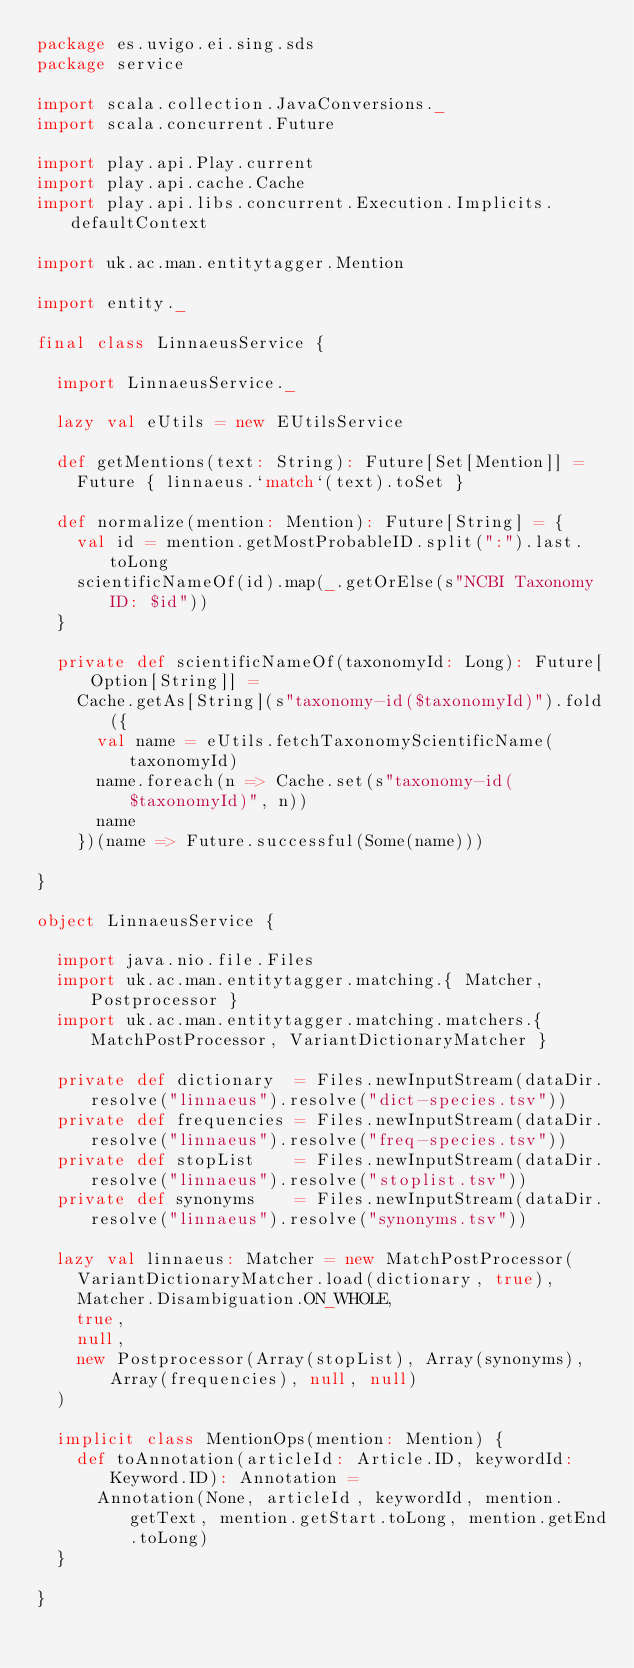Convert code to text. <code><loc_0><loc_0><loc_500><loc_500><_Scala_>package es.uvigo.ei.sing.sds
package service

import scala.collection.JavaConversions._
import scala.concurrent.Future

import play.api.Play.current
import play.api.cache.Cache
import play.api.libs.concurrent.Execution.Implicits.defaultContext

import uk.ac.man.entitytagger.Mention

import entity._

final class LinnaeusService {

  import LinnaeusService._

  lazy val eUtils = new EUtilsService

  def getMentions(text: String): Future[Set[Mention]] =
    Future { linnaeus.`match`(text).toSet }

  def normalize(mention: Mention): Future[String] = {
    val id = mention.getMostProbableID.split(":").last.toLong
    scientificNameOf(id).map(_.getOrElse(s"NCBI Taxonomy ID: $id"))
  }

  private def scientificNameOf(taxonomyId: Long): Future[Option[String]] =
    Cache.getAs[String](s"taxonomy-id($taxonomyId)").fold({
      val name = eUtils.fetchTaxonomyScientificName(taxonomyId)
      name.foreach(n => Cache.set(s"taxonomy-id($taxonomyId)", n))
      name
    })(name => Future.successful(Some(name)))

}

object LinnaeusService {

  import java.nio.file.Files
  import uk.ac.man.entitytagger.matching.{ Matcher, Postprocessor }
  import uk.ac.man.entitytagger.matching.matchers.{ MatchPostProcessor, VariantDictionaryMatcher }

  private def dictionary  = Files.newInputStream(dataDir.resolve("linnaeus").resolve("dict-species.tsv"))
  private def frequencies = Files.newInputStream(dataDir.resolve("linnaeus").resolve("freq-species.tsv"))
  private def stopList    = Files.newInputStream(dataDir.resolve("linnaeus").resolve("stoplist.tsv"))
  private def synonyms    = Files.newInputStream(dataDir.resolve("linnaeus").resolve("synonyms.tsv"))

  lazy val linnaeus: Matcher = new MatchPostProcessor(
    VariantDictionaryMatcher.load(dictionary, true),
    Matcher.Disambiguation.ON_WHOLE,
    true,
    null,
    new Postprocessor(Array(stopList), Array(synonyms), Array(frequencies), null, null)
  )

  implicit class MentionOps(mention: Mention) {
    def toAnnotation(articleId: Article.ID, keywordId: Keyword.ID): Annotation =
      Annotation(None, articleId, keywordId, mention.getText, mention.getStart.toLong, mention.getEnd.toLong)
  }

}
</code> 